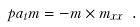<formula> <loc_0><loc_0><loc_500><loc_500>\ p a _ { t } m = - m \times m _ { x x } \ .</formula> 